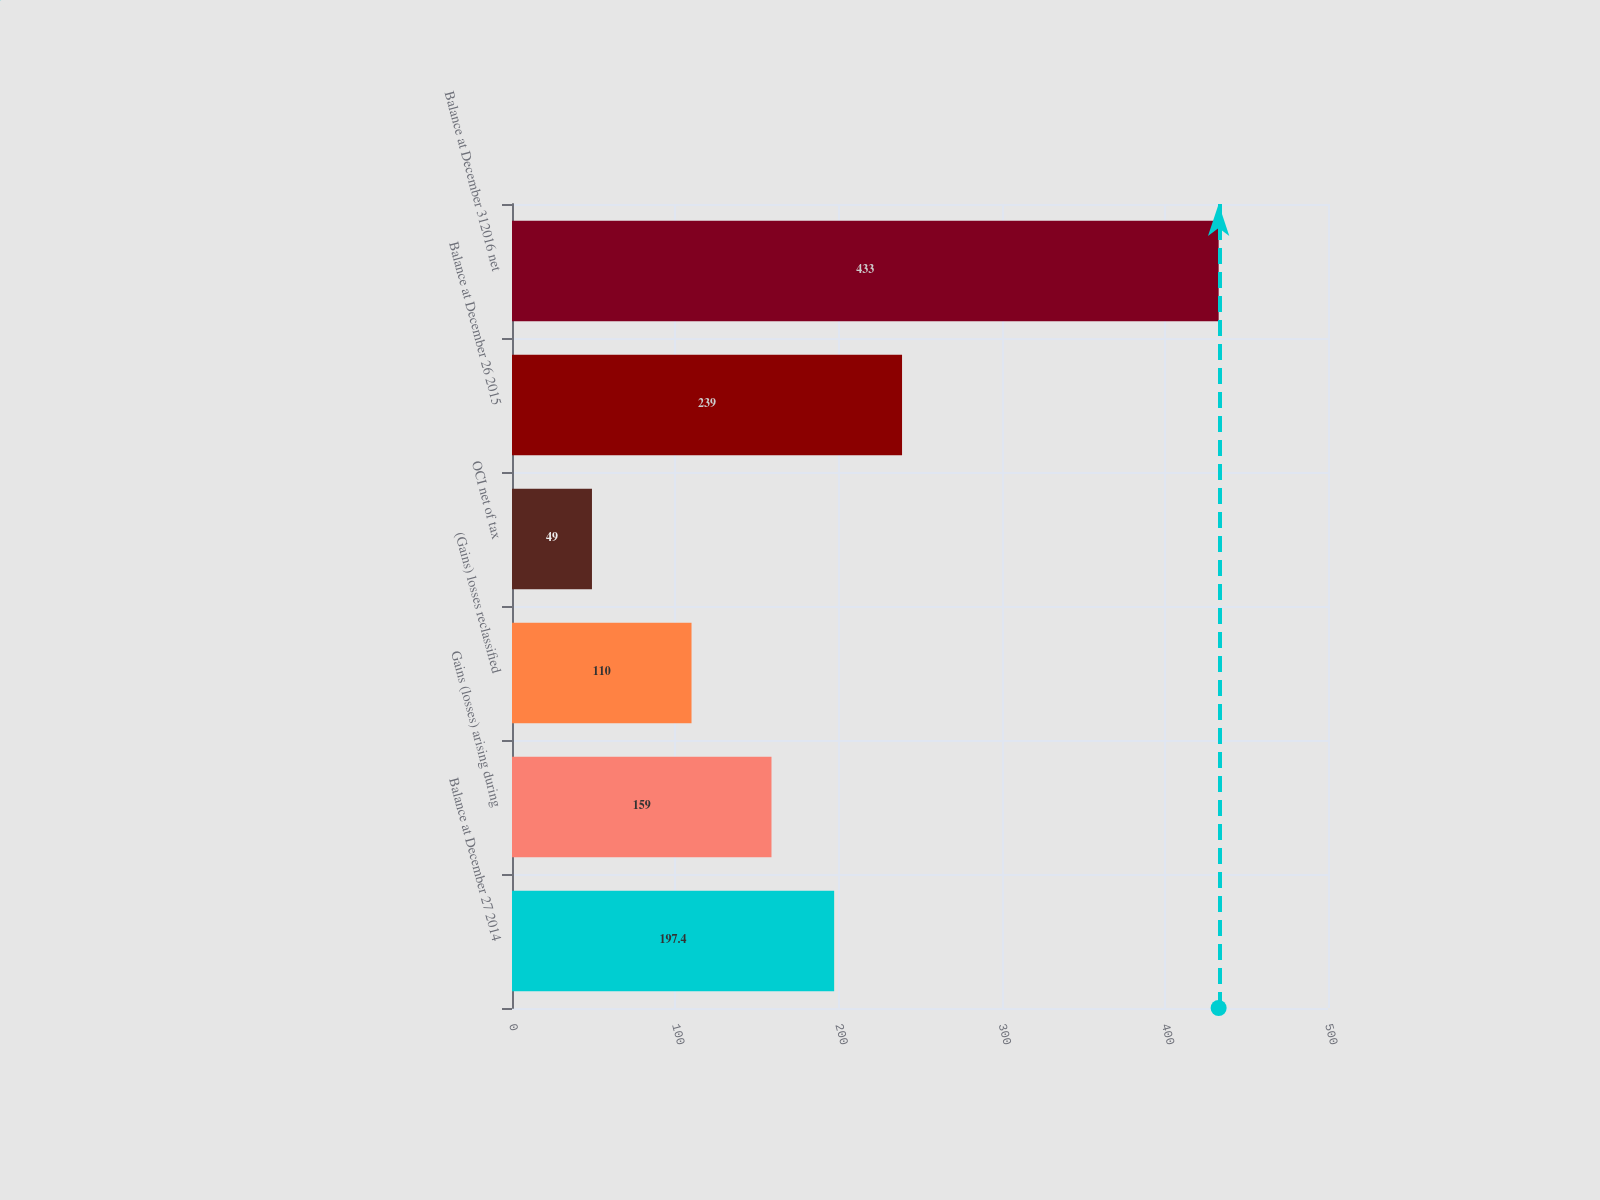Convert chart to OTSL. <chart><loc_0><loc_0><loc_500><loc_500><bar_chart><fcel>Balance at December 27 2014<fcel>Gains (losses) arising during<fcel>(Gains) losses reclassified<fcel>OCI net of tax<fcel>Balance at December 26 2015<fcel>Balance at December 312016 net<nl><fcel>197.4<fcel>159<fcel>110<fcel>49<fcel>239<fcel>433<nl></chart> 